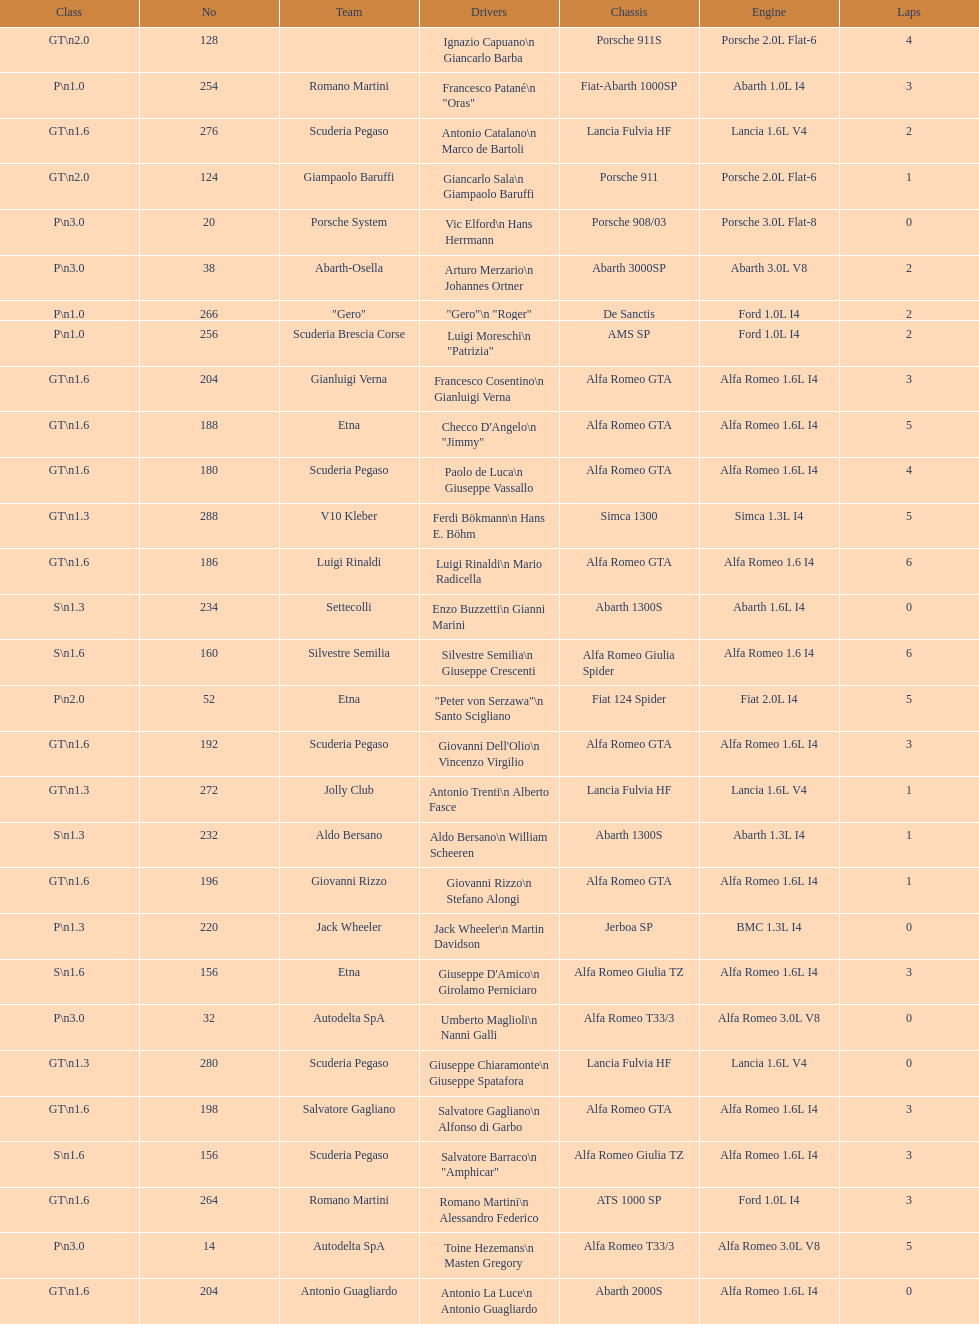What class is below s 1.6? GT 1.6. 